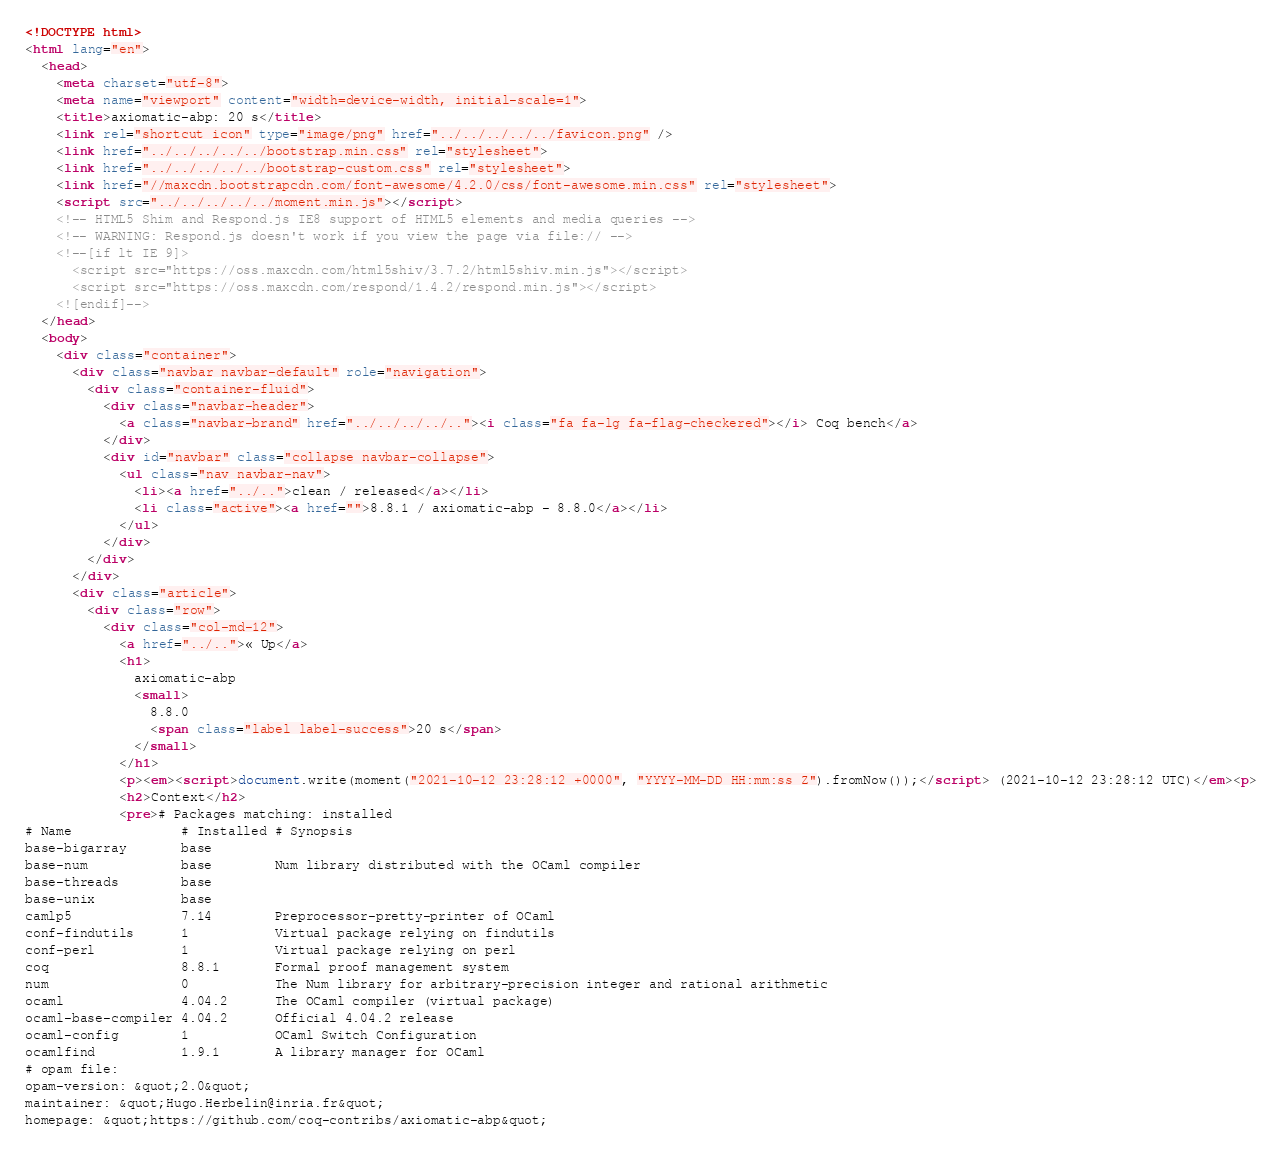<code> <loc_0><loc_0><loc_500><loc_500><_HTML_><!DOCTYPE html>
<html lang="en">
  <head>
    <meta charset="utf-8">
    <meta name="viewport" content="width=device-width, initial-scale=1">
    <title>axiomatic-abp: 20 s</title>
    <link rel="shortcut icon" type="image/png" href="../../../../../favicon.png" />
    <link href="../../../../../bootstrap.min.css" rel="stylesheet">
    <link href="../../../../../bootstrap-custom.css" rel="stylesheet">
    <link href="//maxcdn.bootstrapcdn.com/font-awesome/4.2.0/css/font-awesome.min.css" rel="stylesheet">
    <script src="../../../../../moment.min.js"></script>
    <!-- HTML5 Shim and Respond.js IE8 support of HTML5 elements and media queries -->
    <!-- WARNING: Respond.js doesn't work if you view the page via file:// -->
    <!--[if lt IE 9]>
      <script src="https://oss.maxcdn.com/html5shiv/3.7.2/html5shiv.min.js"></script>
      <script src="https://oss.maxcdn.com/respond/1.4.2/respond.min.js"></script>
    <![endif]-->
  </head>
  <body>
    <div class="container">
      <div class="navbar navbar-default" role="navigation">
        <div class="container-fluid">
          <div class="navbar-header">
            <a class="navbar-brand" href="../../../../.."><i class="fa fa-lg fa-flag-checkered"></i> Coq bench</a>
          </div>
          <div id="navbar" class="collapse navbar-collapse">
            <ul class="nav navbar-nav">
              <li><a href="../..">clean / released</a></li>
              <li class="active"><a href="">8.8.1 / axiomatic-abp - 8.8.0</a></li>
            </ul>
          </div>
        </div>
      </div>
      <div class="article">
        <div class="row">
          <div class="col-md-12">
            <a href="../..">« Up</a>
            <h1>
              axiomatic-abp
              <small>
                8.8.0
                <span class="label label-success">20 s</span>
              </small>
            </h1>
            <p><em><script>document.write(moment("2021-10-12 23:28:12 +0000", "YYYY-MM-DD HH:mm:ss Z").fromNow());</script> (2021-10-12 23:28:12 UTC)</em><p>
            <h2>Context</h2>
            <pre># Packages matching: installed
# Name              # Installed # Synopsis
base-bigarray       base
base-num            base        Num library distributed with the OCaml compiler
base-threads        base
base-unix           base
camlp5              7.14        Preprocessor-pretty-printer of OCaml
conf-findutils      1           Virtual package relying on findutils
conf-perl           1           Virtual package relying on perl
coq                 8.8.1       Formal proof management system
num                 0           The Num library for arbitrary-precision integer and rational arithmetic
ocaml               4.04.2      The OCaml compiler (virtual package)
ocaml-base-compiler 4.04.2      Official 4.04.2 release
ocaml-config        1           OCaml Switch Configuration
ocamlfind           1.9.1       A library manager for OCaml
# opam file:
opam-version: &quot;2.0&quot;
maintainer: &quot;Hugo.Herbelin@inria.fr&quot;
homepage: &quot;https://github.com/coq-contribs/axiomatic-abp&quot;</code> 